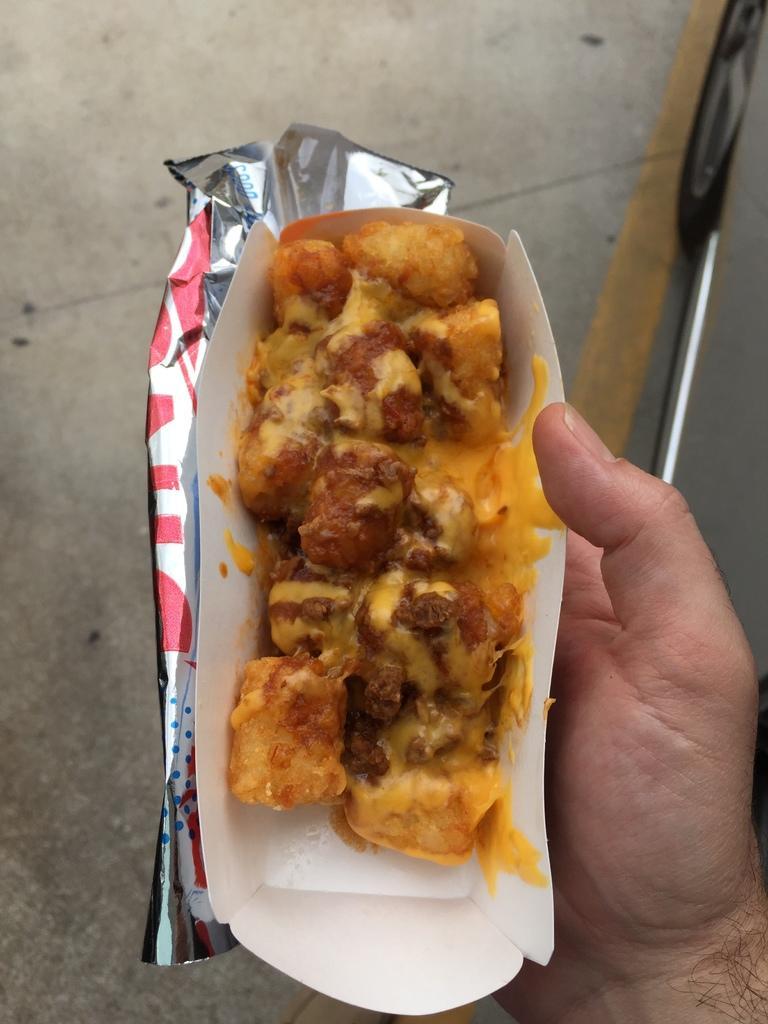Can you describe this image briefly? There is a person holding an edible which is placed on an object in his hand. 